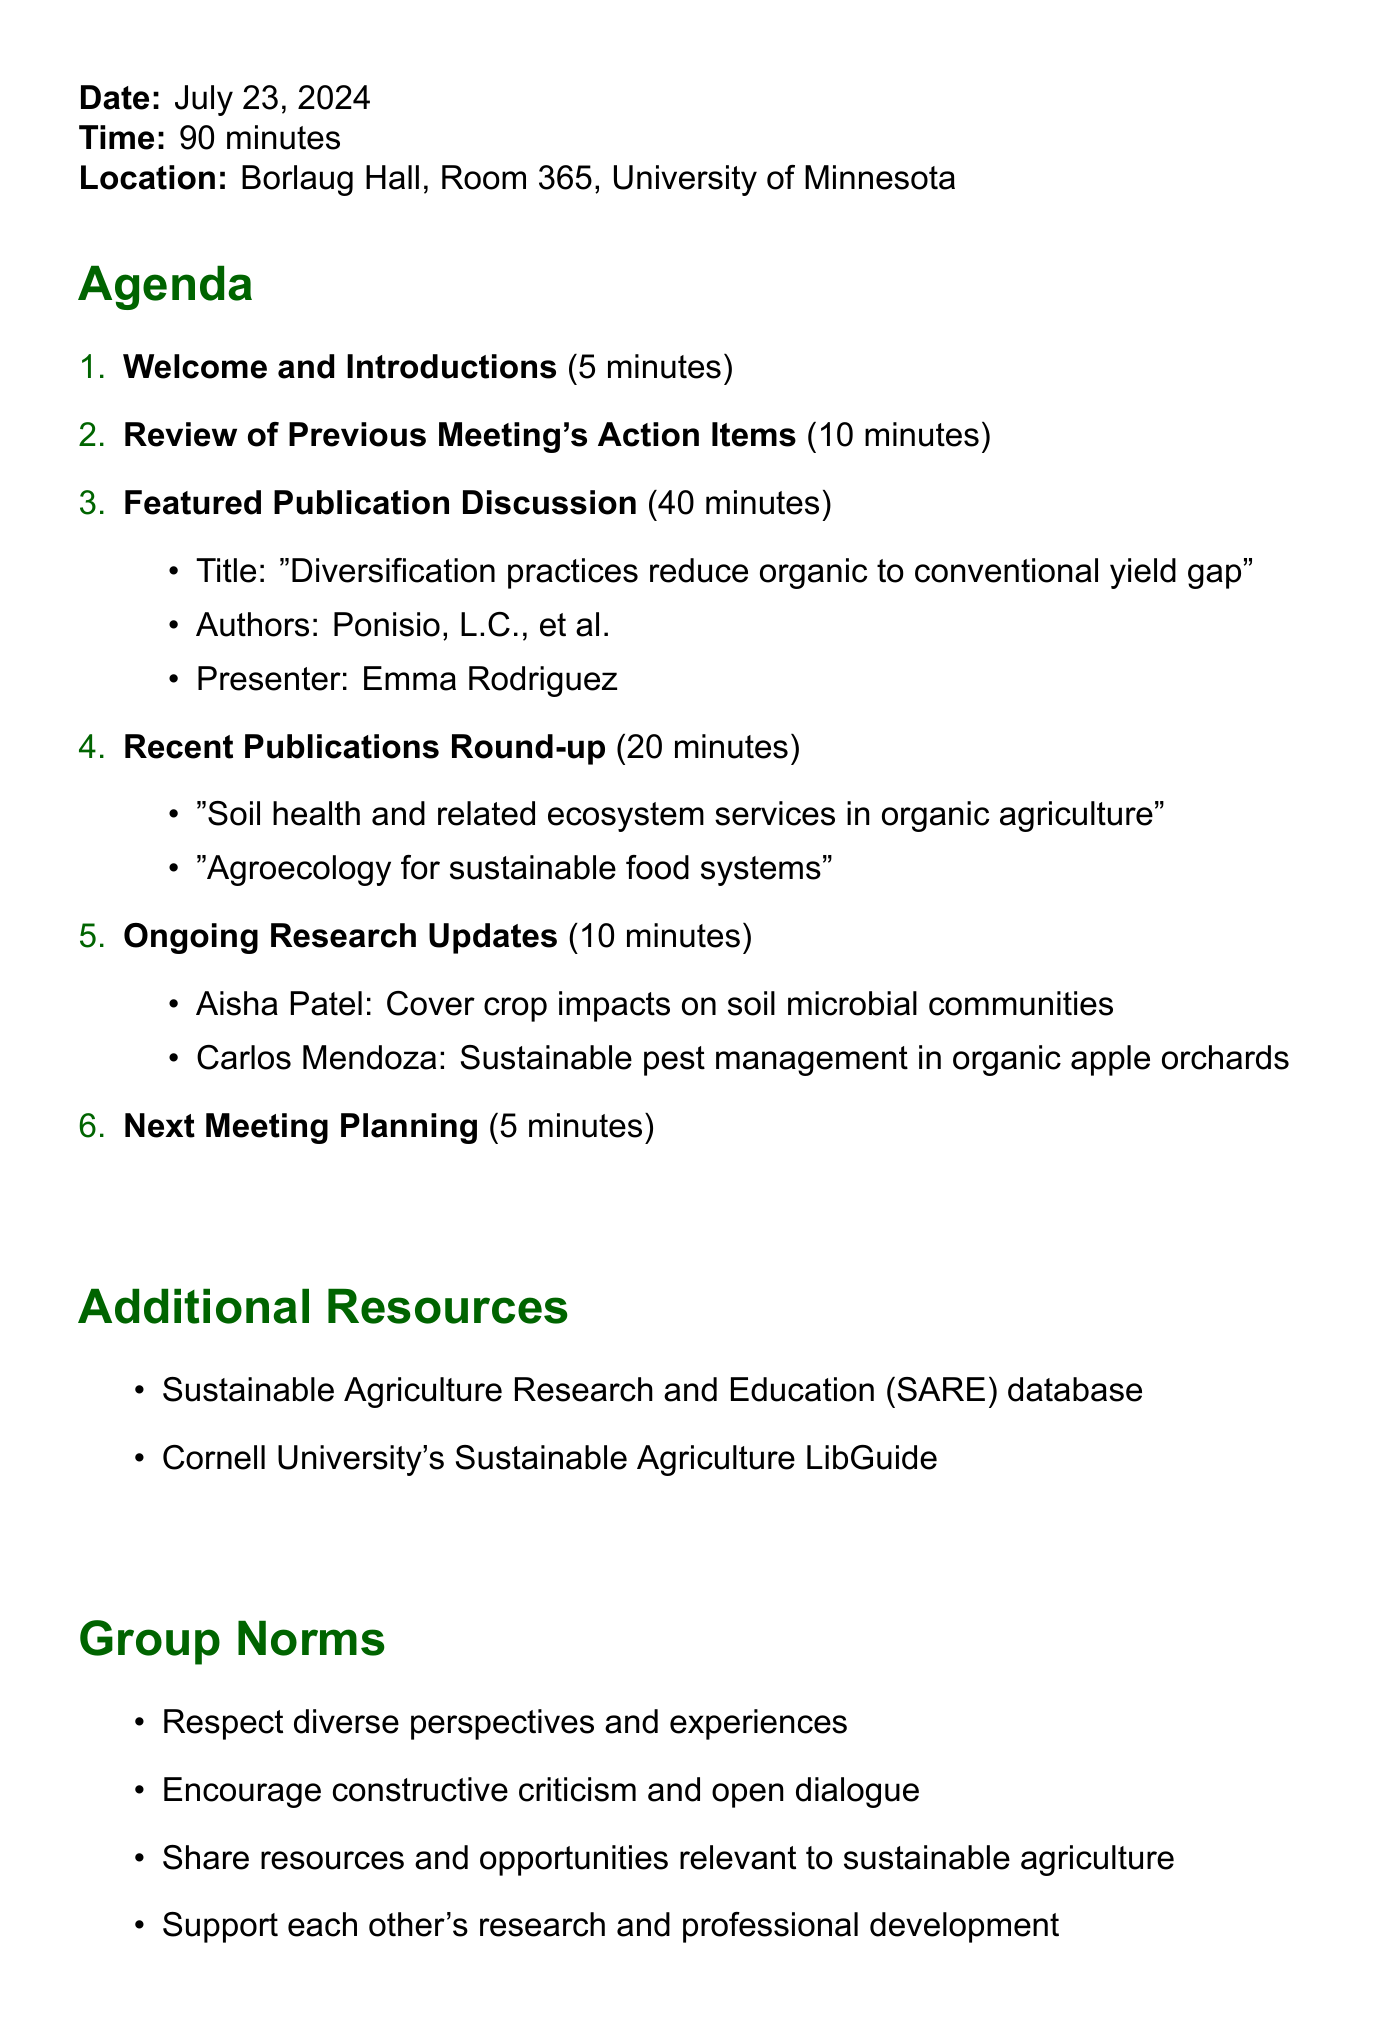What is the name of the journal club? The document states the name of the journal club at the beginning.
Answer: Sustainable Agriculture and Agroecology Journal Club How long is the duration of the meeting? The duration of the meeting is mentioned in the meeting details section.
Answer: 90 minutes What is the title of the featured publication? The featured publication's title is provided in the agenda item discussing it.
Answer: Diversification practices reduce organic to conventional yield gap Who is the presenter for the featured publication discussion? The presenter's name is specified under the featured publication discussion.
Answer: Emma Rodriguez How many recent publications are mentioned in the recent publications round-up? The count of publications is derived from the list provided in the agenda item.
Answer: 2 What is the location of the meeting? The meeting's location is found in the meeting details section.
Answer: Borlaug Hall, Room 365, University of Minnesota What is one of the ongoing research projects mentioned? The document lists ongoing research projects under updates.
Answer: Cover crop impacts on soil microbial communities How many minutes are allocated for the recent publications round-up? The time for this agenda item is specifically mentioned.
Answer: 20 minutes What are the group norms focused on? The group norms are listed at the end of the document.
Answer: Respect diverse perspectives and experiences 